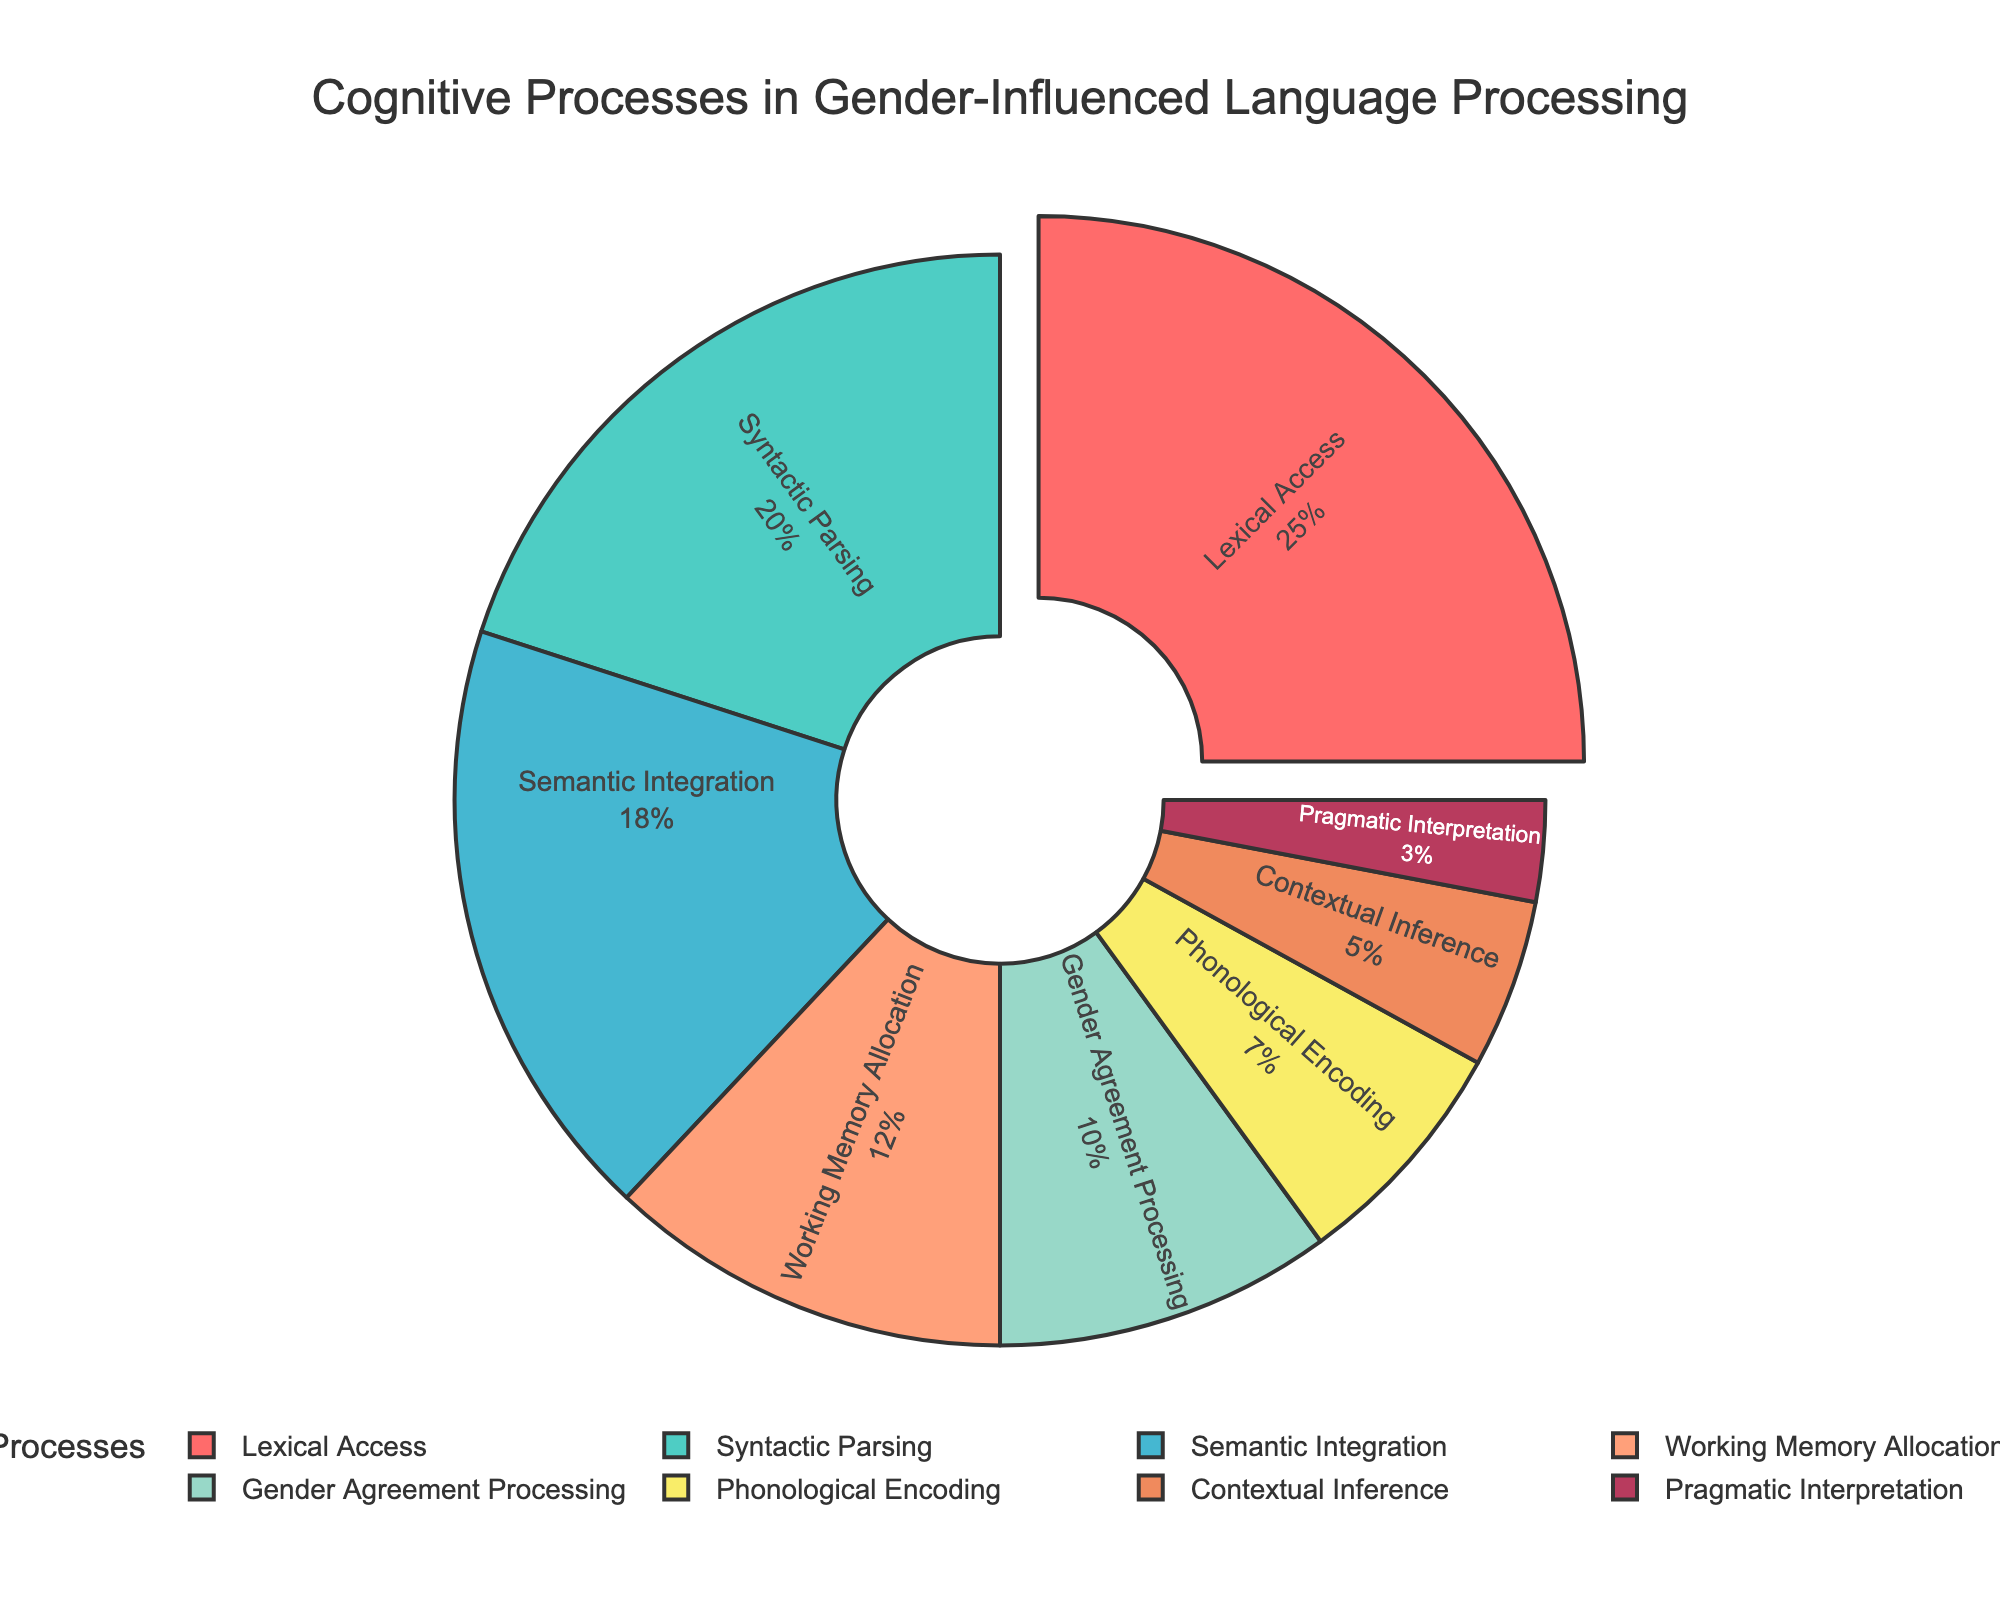What process occupies the largest portion of the pie chart? The largest portion of the pie chart can be identified visually by looking at the section with the most surface area. The label inside this section will indicate the process it represents. In this case, it is "Lexical Access" which occupies the largest portion.
Answer: Lexical Access Which two cognitive processes together make up nearly half of the total percentage? To determine this, identify the two largest sections of the pie chart and add their percentages. "Lexical Access" (25%) and "Syntactic Parsing" (20%) together make up 25% + 20% = 45%, which is nearly half of the total.
Answer: Lexical Access and Syntactic Parsing What is the combined percentage of less prominent processes such as Phonological Encoding, Contextual Inference, and Pragmatic Interpretation? Sum the percentages of Phonological Encoding (7%), Contextual Inference (5%), and Pragmatic Interpretation (3%). The combined percentage is 7% + 5% + 3% = 15%.
Answer: 15% Which cognitive process occupies the smallest portion of the pie chart? The smallest portion can be identified visually by looking at the section with the least surface area. The label inside this section will indicate the process it represents. In this case, it is "Pragmatic Interpretation" with 3%.
Answer: Pragmatic Interpretation Is Gender Agreement Processing a significant portion compared to Working Memory Allocation? Compare the percentages of Gender Agreement Processing (10%) and Working Memory Allocation (12%). Working Memory Allocation is slightly larger by 2%.
Answer: No What is the difference in percentage between Semantic Integration and Contextual Inference? Subtract the percentage of Contextual Inference (5%) from Semantic Integration (18%). The difference is 18% - 5% = 13%.
Answer: 13% If Lexical Access is considered as the baseline, what percentage less is Phonological Encoding? Calculate how much less Phonological Encoding (7%) is compared to Lexical Access (25%). The difference is 25% - 7% = 18%.
Answer: 18% What percentage of the pie chart is devoted to processes related to syntax (Syntactic Parsing and Gender Agreement Processing)? Add the percentages of Syntactic Parsing (20%) and Gender Agreement Processing (10%). The total is 20% + 10% = 30%.
Answer: 30% Which process is highlighted, and why might it be highlighted in the figure? The highlighted process can be identified visually as the section that is slightly pulled out from the rest of the pie chart. In this case, it is "Lexical Access". The highlighting could signify its importance or the fact that it occupies the largest portion.
Answer: Lexical Access How does the percentage of Syntactic Parsing compare to the total percentage of both Semantic Integration and Working Memory Allocation? First, find the total percentage of Semantic Integration (18%) and Working Memory Allocation (12%) which is 18% + 12% = 30%. Syntactic Parsing is 20%, so it is 10% less than the combined total of Semantic Integration and Working Memory Allocation.
Answer: 10% less 